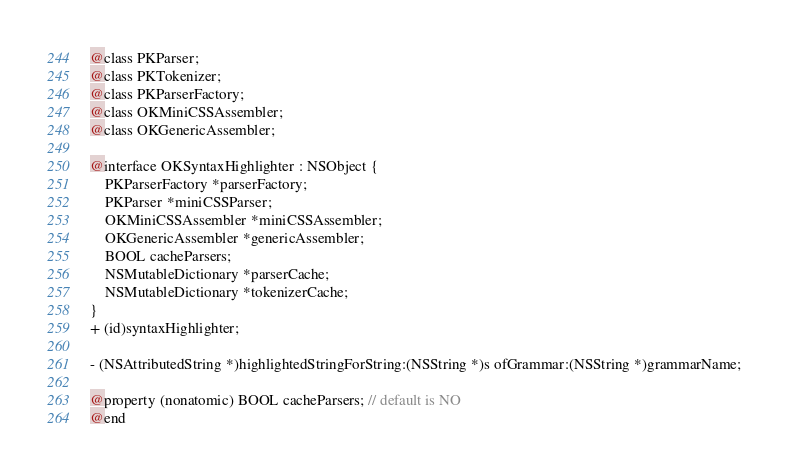Convert code to text. <code><loc_0><loc_0><loc_500><loc_500><_C_>
@class PKParser;
@class PKTokenizer;
@class PKParserFactory;
@class OKMiniCSSAssembler;
@class OKGenericAssembler;

@interface OKSyntaxHighlighter : NSObject {
    PKParserFactory *parserFactory;
    PKParser *miniCSSParser;
    OKMiniCSSAssembler *miniCSSAssembler;
    OKGenericAssembler *genericAssembler;
    BOOL cacheParsers;
    NSMutableDictionary *parserCache;
    NSMutableDictionary *tokenizerCache;
}
+ (id)syntaxHighlighter;

- (NSAttributedString *)highlightedStringForString:(NSString *)s ofGrammar:(NSString *)grammarName;

@property (nonatomic) BOOL cacheParsers; // default is NO
@end
</code> 